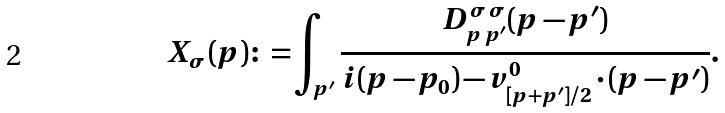<formula> <loc_0><loc_0><loc_500><loc_500>X _ { \sigma } ( p ) { \colon = } \int _ { p ^ { \prime } } \frac { D _ { { p } \, { p } ^ { \prime } } ^ { \sigma \, \sigma } ( p - p ^ { \prime } ) } { i ( p - p _ { 0 } ) - { v } ^ { 0 } _ { [ { p } + { p } ^ { \prime } ] / 2 } \cdot ( { p } - { p } ^ { \prime } ) } .</formula> 